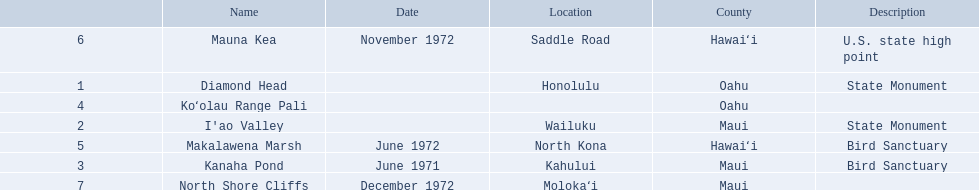What are all of the landmark names? Diamond Head, I'ao Valley, Kanaha Pond, Koʻolau Range Pali, Makalawena Marsh, Mauna Kea, North Shore Cliffs. Where are they located? Honolulu, Wailuku, Kahului, , North Kona, Saddle Road, Molokaʻi. And which landmark has no listed location? Koʻolau Range Pali. 